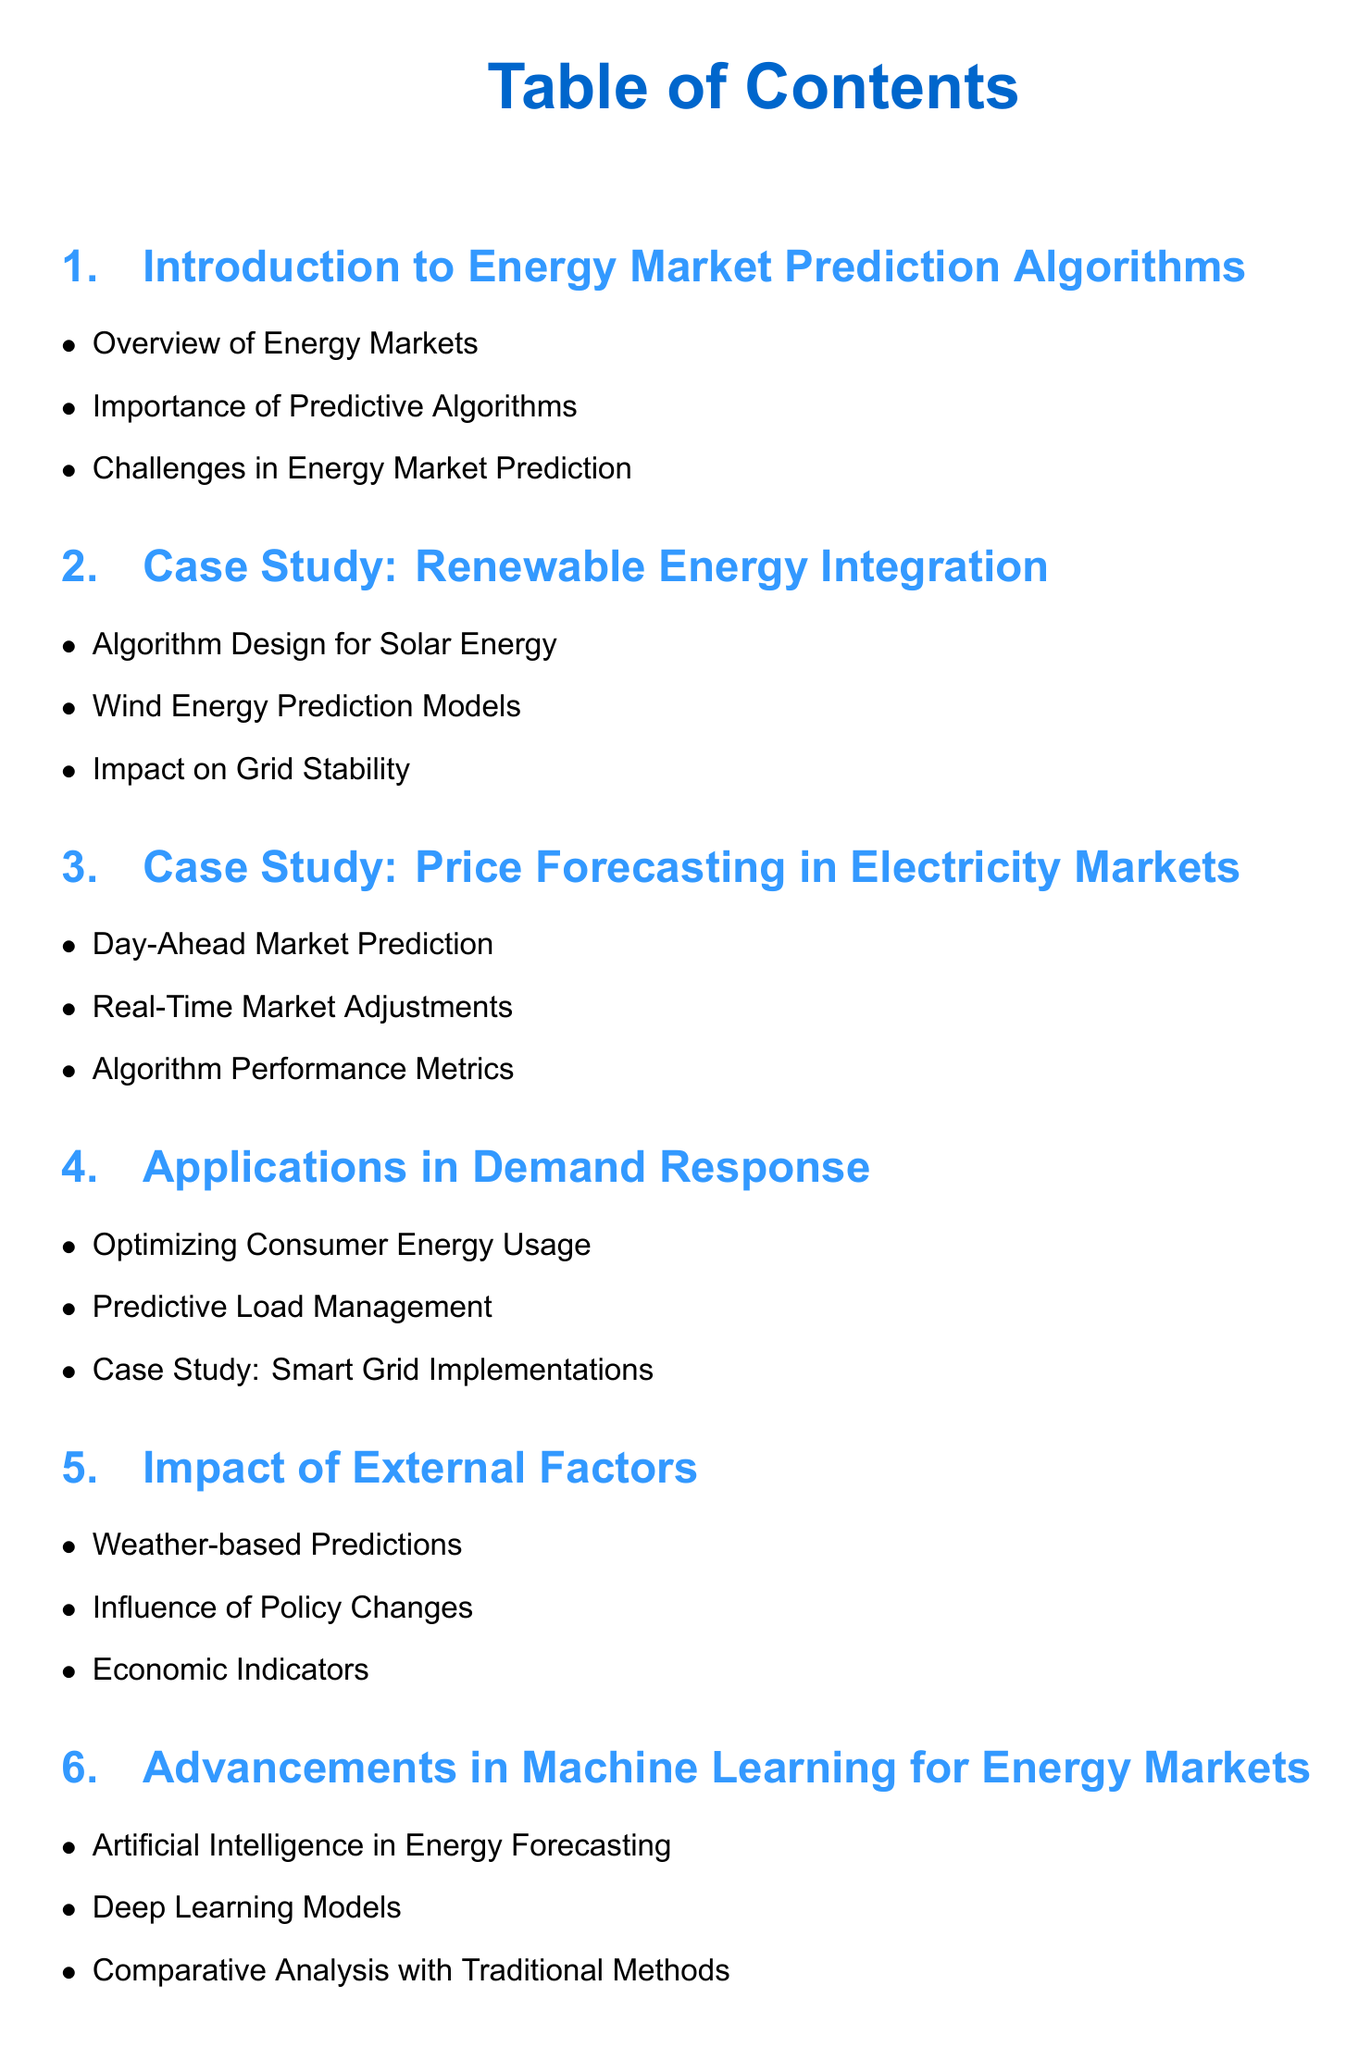What is the title of the first section? The title of the first section is listed in the Table of Contents as it appears, which is "Introduction to Energy Market Prediction Algorithms."
Answer: Introduction to Energy Market Prediction Algorithms How many case studies are presented in the document? The document lists two case study sections, one for renewable energy and another for price forecasting in electricity markets.
Answer: 2 What does the third section focus on? The third section's title directly indicates its focus, which is on "Price Forecasting in Electricity Markets."
Answer: Price Forecasting in Electricity Markets What is one application mentioned in the document? The document outlines several applications, but one specifically mentioned is "Demand Response."
Answer: Demand Response Which factor is considered in the section about external influences? The section discusses various factors, one of which is "Weather-based Predictions."
Answer: Weather-based Predictions How many applications are listed under the "Applications in Demand Response" section? There are three specific applications detailed in that section, as indicated by the bullet points under it.
Answer: 3 What is the last section titled? The title of the last section is provided prominently in the Table of Contents as it concludes the document.
Answer: Conclusion and Future Research Directions What is one of the advancements discussed in machine learning for energy markets? The section about advancements lists several items, one of which is "Artificial Intelligence in Energy Forecasting."
Answer: Artificial Intelligence in Energy Forecasting What is stated as a challenge in energy market prediction? Challenges in energy market prediction are introduced in the first section, indicating they play a critical role in algorithm development.
Answer: Challenges in Energy Market Prediction 